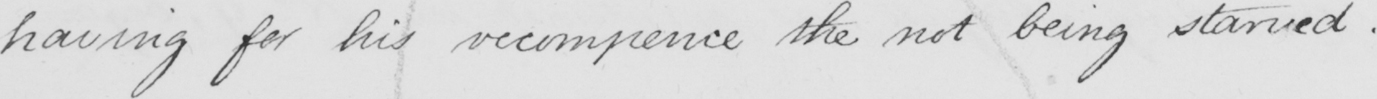What is written in this line of handwriting? having for his recompence the not being starved .  _ 